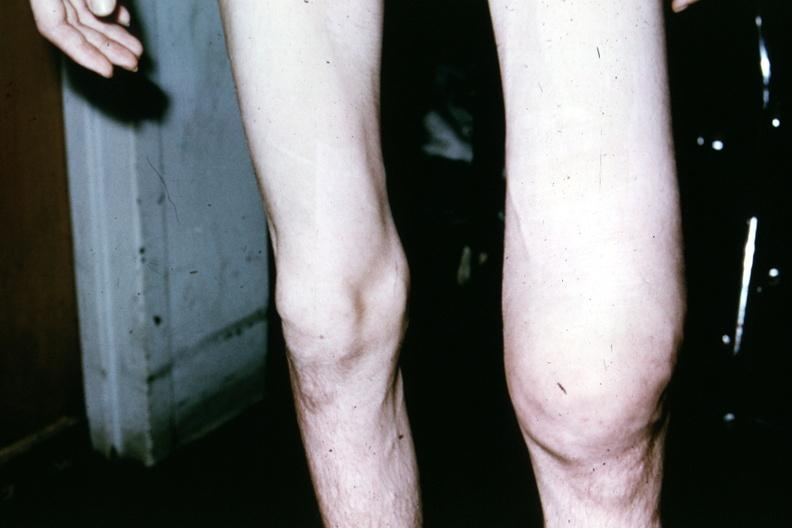what is present?
Answer the question using a single word or phrase. Joints 